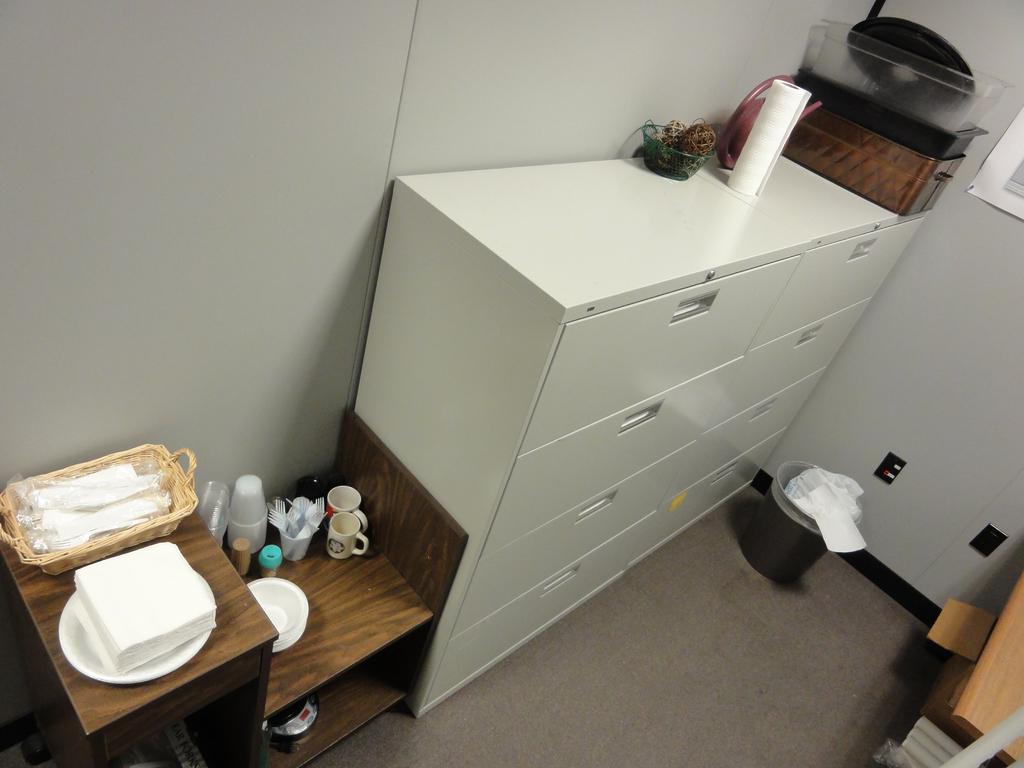How would you summarize this image in a sentence or two? In the middle there is a wardrobe on that there is a bowl. In the middle there is a dustbin. On the left there is a table on that ,there is a table ,tissues ,cup and glass. 